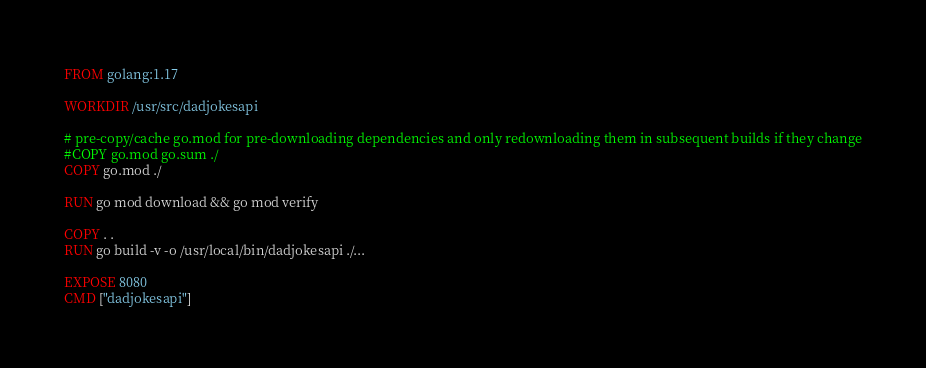Convert code to text. <code><loc_0><loc_0><loc_500><loc_500><_Dockerfile_>FROM golang:1.17

WORKDIR /usr/src/dadjokesapi

# pre-copy/cache go.mod for pre-downloading dependencies and only redownloading them in subsequent builds if they change
#COPY go.mod go.sum ./
COPY go.mod ./

RUN go mod download && go mod verify

COPY . .
RUN go build -v -o /usr/local/bin/dadjokesapi ./...

EXPOSE 8080
CMD ["dadjokesapi"]
</code> 